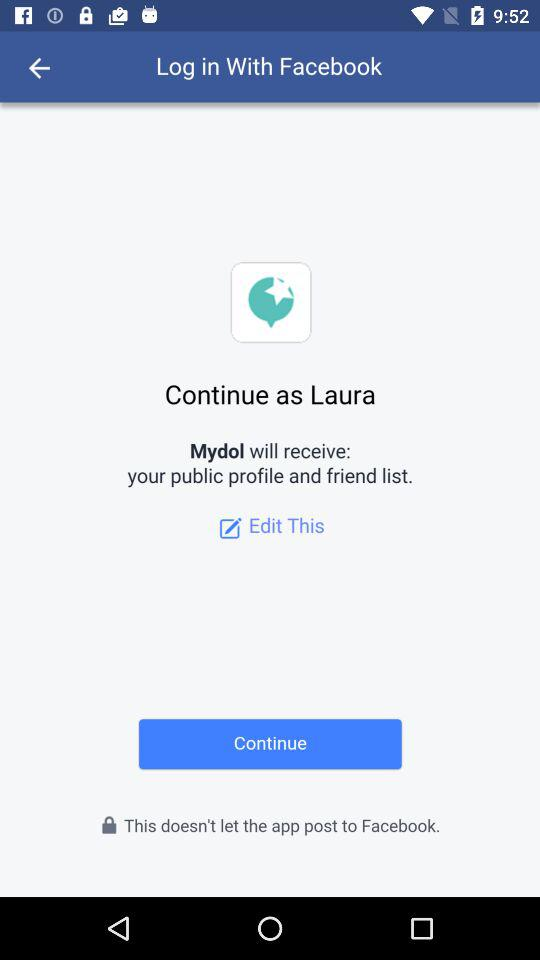Through what application can we log in? You can log in with "Facebook". 